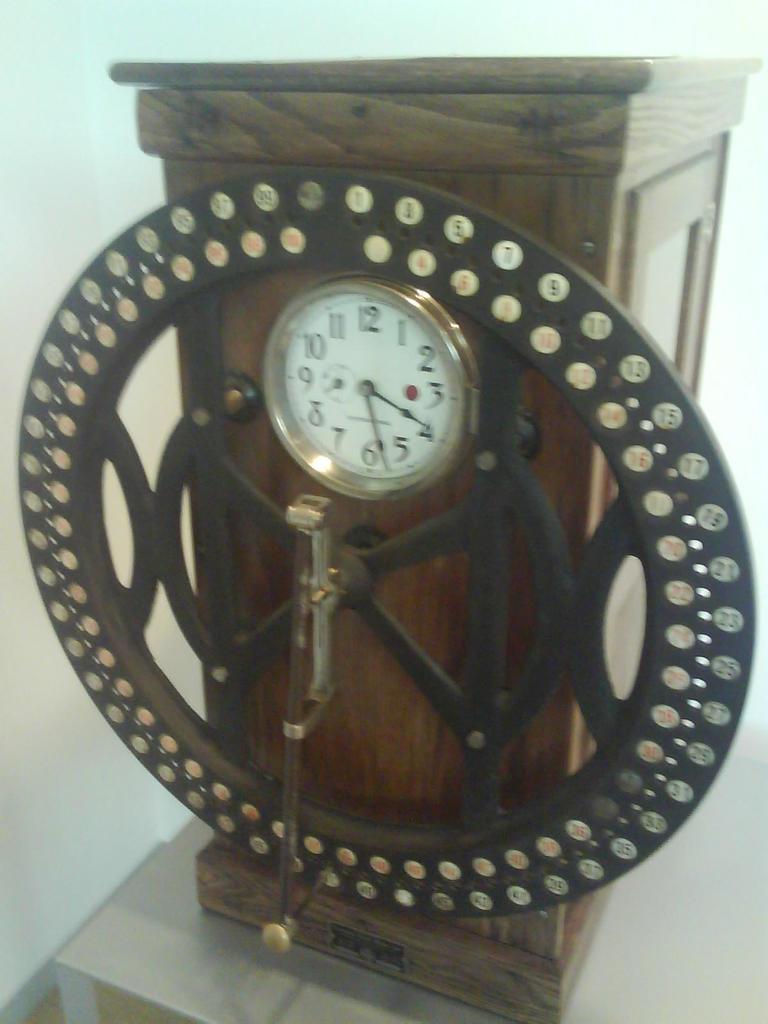What is the time on the clock?
Your response must be concise. 3:27. What number is next to the red circle?
Provide a short and direct response. 3. 